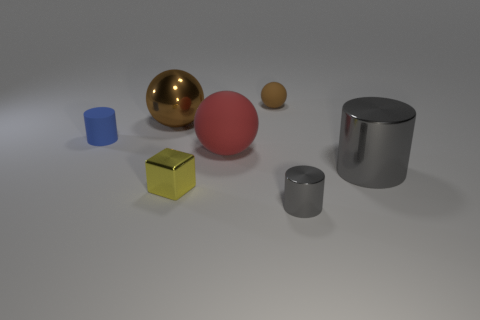How many other objects are there of the same size as the red sphere?
Your response must be concise. 2. What number of big things are blocks or brown shiny blocks?
Provide a short and direct response. 0. There is a red sphere; does it have the same size as the cylinder on the left side of the tiny brown ball?
Provide a short and direct response. No. What number of other things are the same shape as the small blue thing?
Make the answer very short. 2. There is a small blue object that is the same material as the big red ball; what is its shape?
Your response must be concise. Cylinder. Are any big green rubber cylinders visible?
Offer a terse response. No. Is the number of red matte balls on the left side of the big red sphere less than the number of objects that are in front of the large gray shiny thing?
Your response must be concise. Yes. What shape is the tiny object behind the small blue rubber cylinder?
Your answer should be very brief. Sphere. Is the tiny block made of the same material as the tiny brown ball?
Provide a short and direct response. No. There is another large object that is the same shape as the red thing; what is it made of?
Offer a terse response. Metal. 